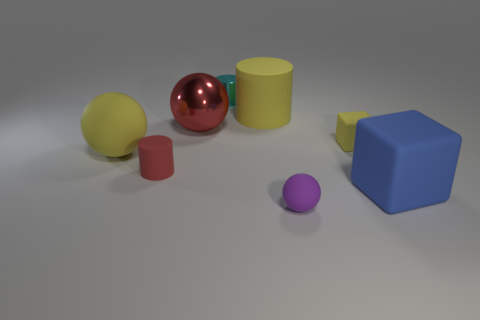What textures can you identify among the objects? In the image, we can observe a variety of textures. The red spherical object has a reflective, glossy surface, while the yellow and blue objects appear matte. The small purple ball also seems to have a smooth, perhaps slightly shiny surface. 